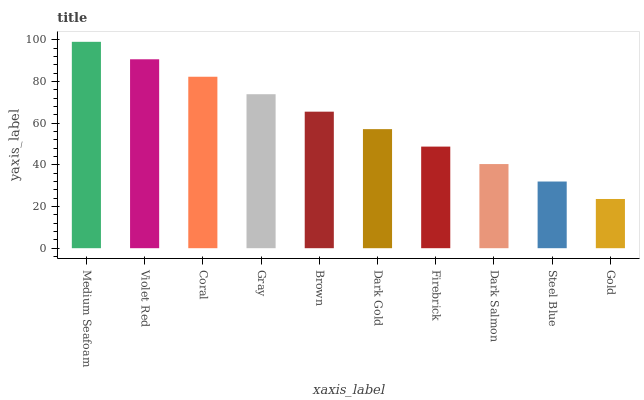Is Gold the minimum?
Answer yes or no. Yes. Is Medium Seafoam the maximum?
Answer yes or no. Yes. Is Violet Red the minimum?
Answer yes or no. No. Is Violet Red the maximum?
Answer yes or no. No. Is Medium Seafoam greater than Violet Red?
Answer yes or no. Yes. Is Violet Red less than Medium Seafoam?
Answer yes or no. Yes. Is Violet Red greater than Medium Seafoam?
Answer yes or no. No. Is Medium Seafoam less than Violet Red?
Answer yes or no. No. Is Brown the high median?
Answer yes or no. Yes. Is Dark Gold the low median?
Answer yes or no. Yes. Is Dark Salmon the high median?
Answer yes or no. No. Is Gray the low median?
Answer yes or no. No. 